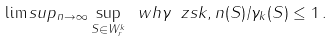<formula> <loc_0><loc_0><loc_500><loc_500>\lim s u p _ { n \to \infty } \sup _ { S \in W ^ { k } _ { r } } \ w h { \gamma } _ { \ } z s { k , n } ( S ) / \gamma _ { k } ( S ) \leq 1 \, .</formula> 